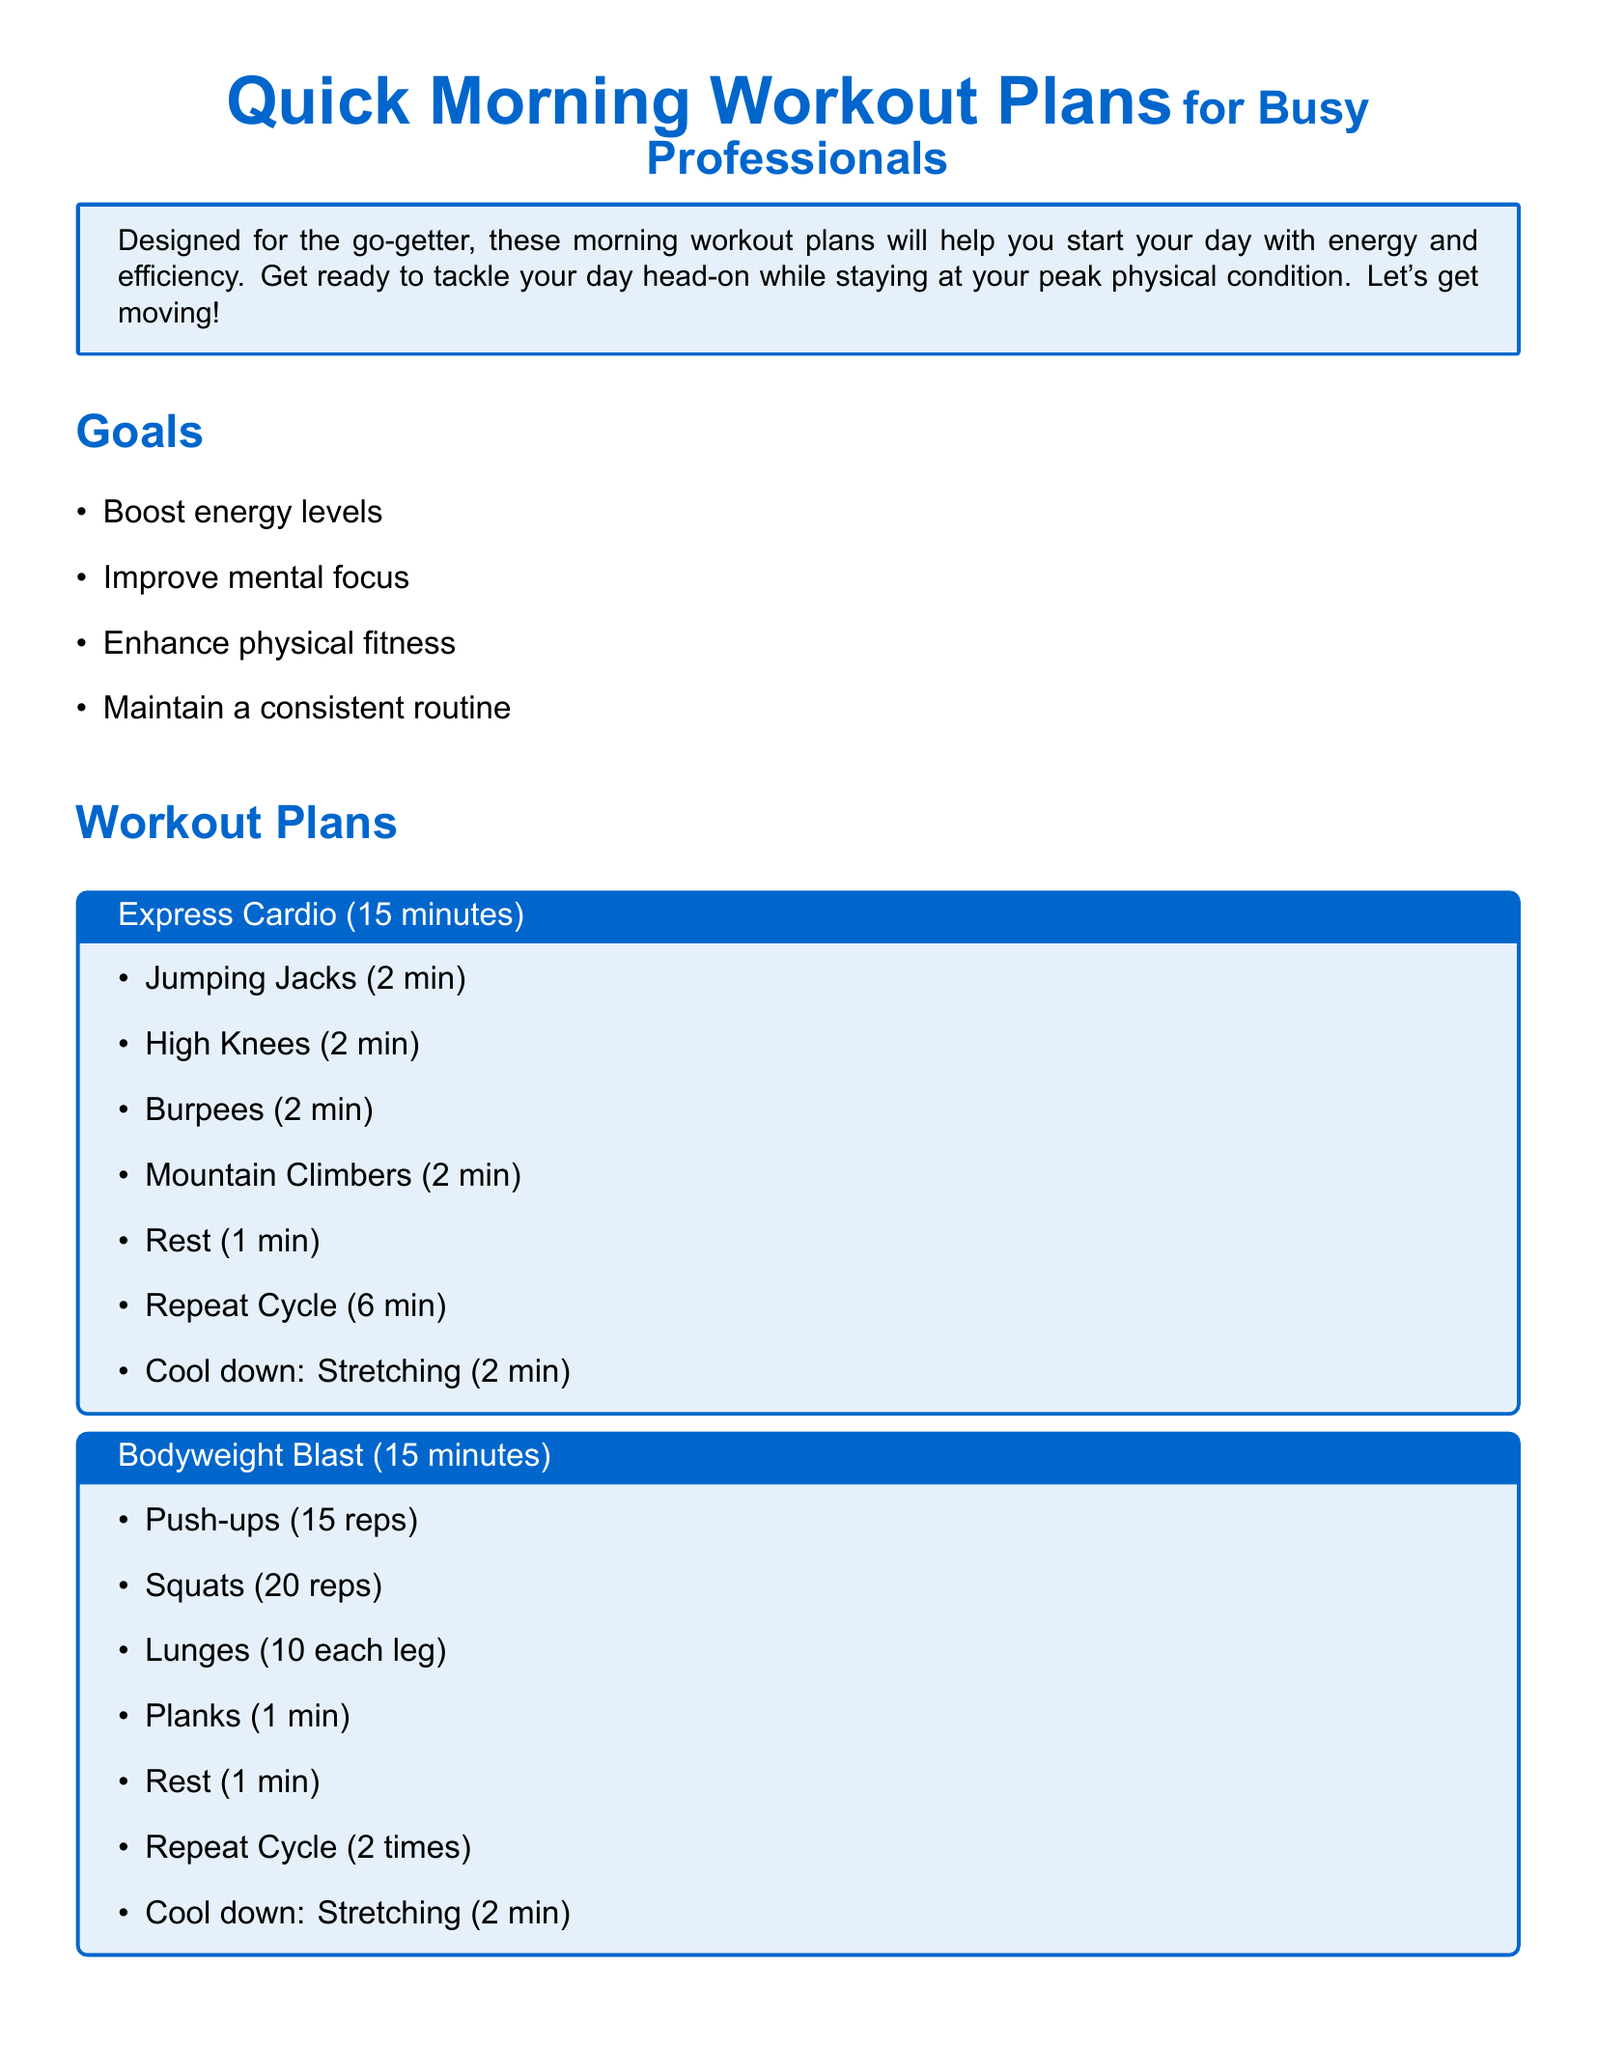What is the title of the document? The document is titled "Quick Morning Workout Plans for Busy Professionals."
Answer: Quick Morning Workout Plans for Busy Professionals How many minutes is the Express Cardio workout? The Express Cardio workout is specified as lasting 15 minutes in the document.
Answer: 15 minutes What is the goal of these workout plans? The document lists several goals including boosting energy levels, improving mental focus, and enhancing physical fitness.
Answer: Boost energy levels How many reps of Squats are included in the Bodyweight Blast? The Bodyweight Blast includes 20 reps of Squats.
Answer: 20 reps What is one tip mentioned for preparing for workouts? The document suggests laying out workout clothes the night before to save time.
Answer: Lay out your workout clothes What is the duration of the Yoga Energizer workout? The Yoga Energizer workout is noted to last for 20 minutes.
Answer: 20 minutes How many times should the Bodyweight Blast cycle be repeated? The Bodyweight Blast cycle should be repeated 2 times according to the document.
Answer: 2 times What is the last activity in the Yoga Energizer? The last activity in the Yoga Energizer is Breathing Meditation for 3 minutes.
Answer: Breathing Meditation What color is used for the box titles in the document? The box titles in the document use a specific color defined as RGB(0,102,204).
Answer: titlecolor 